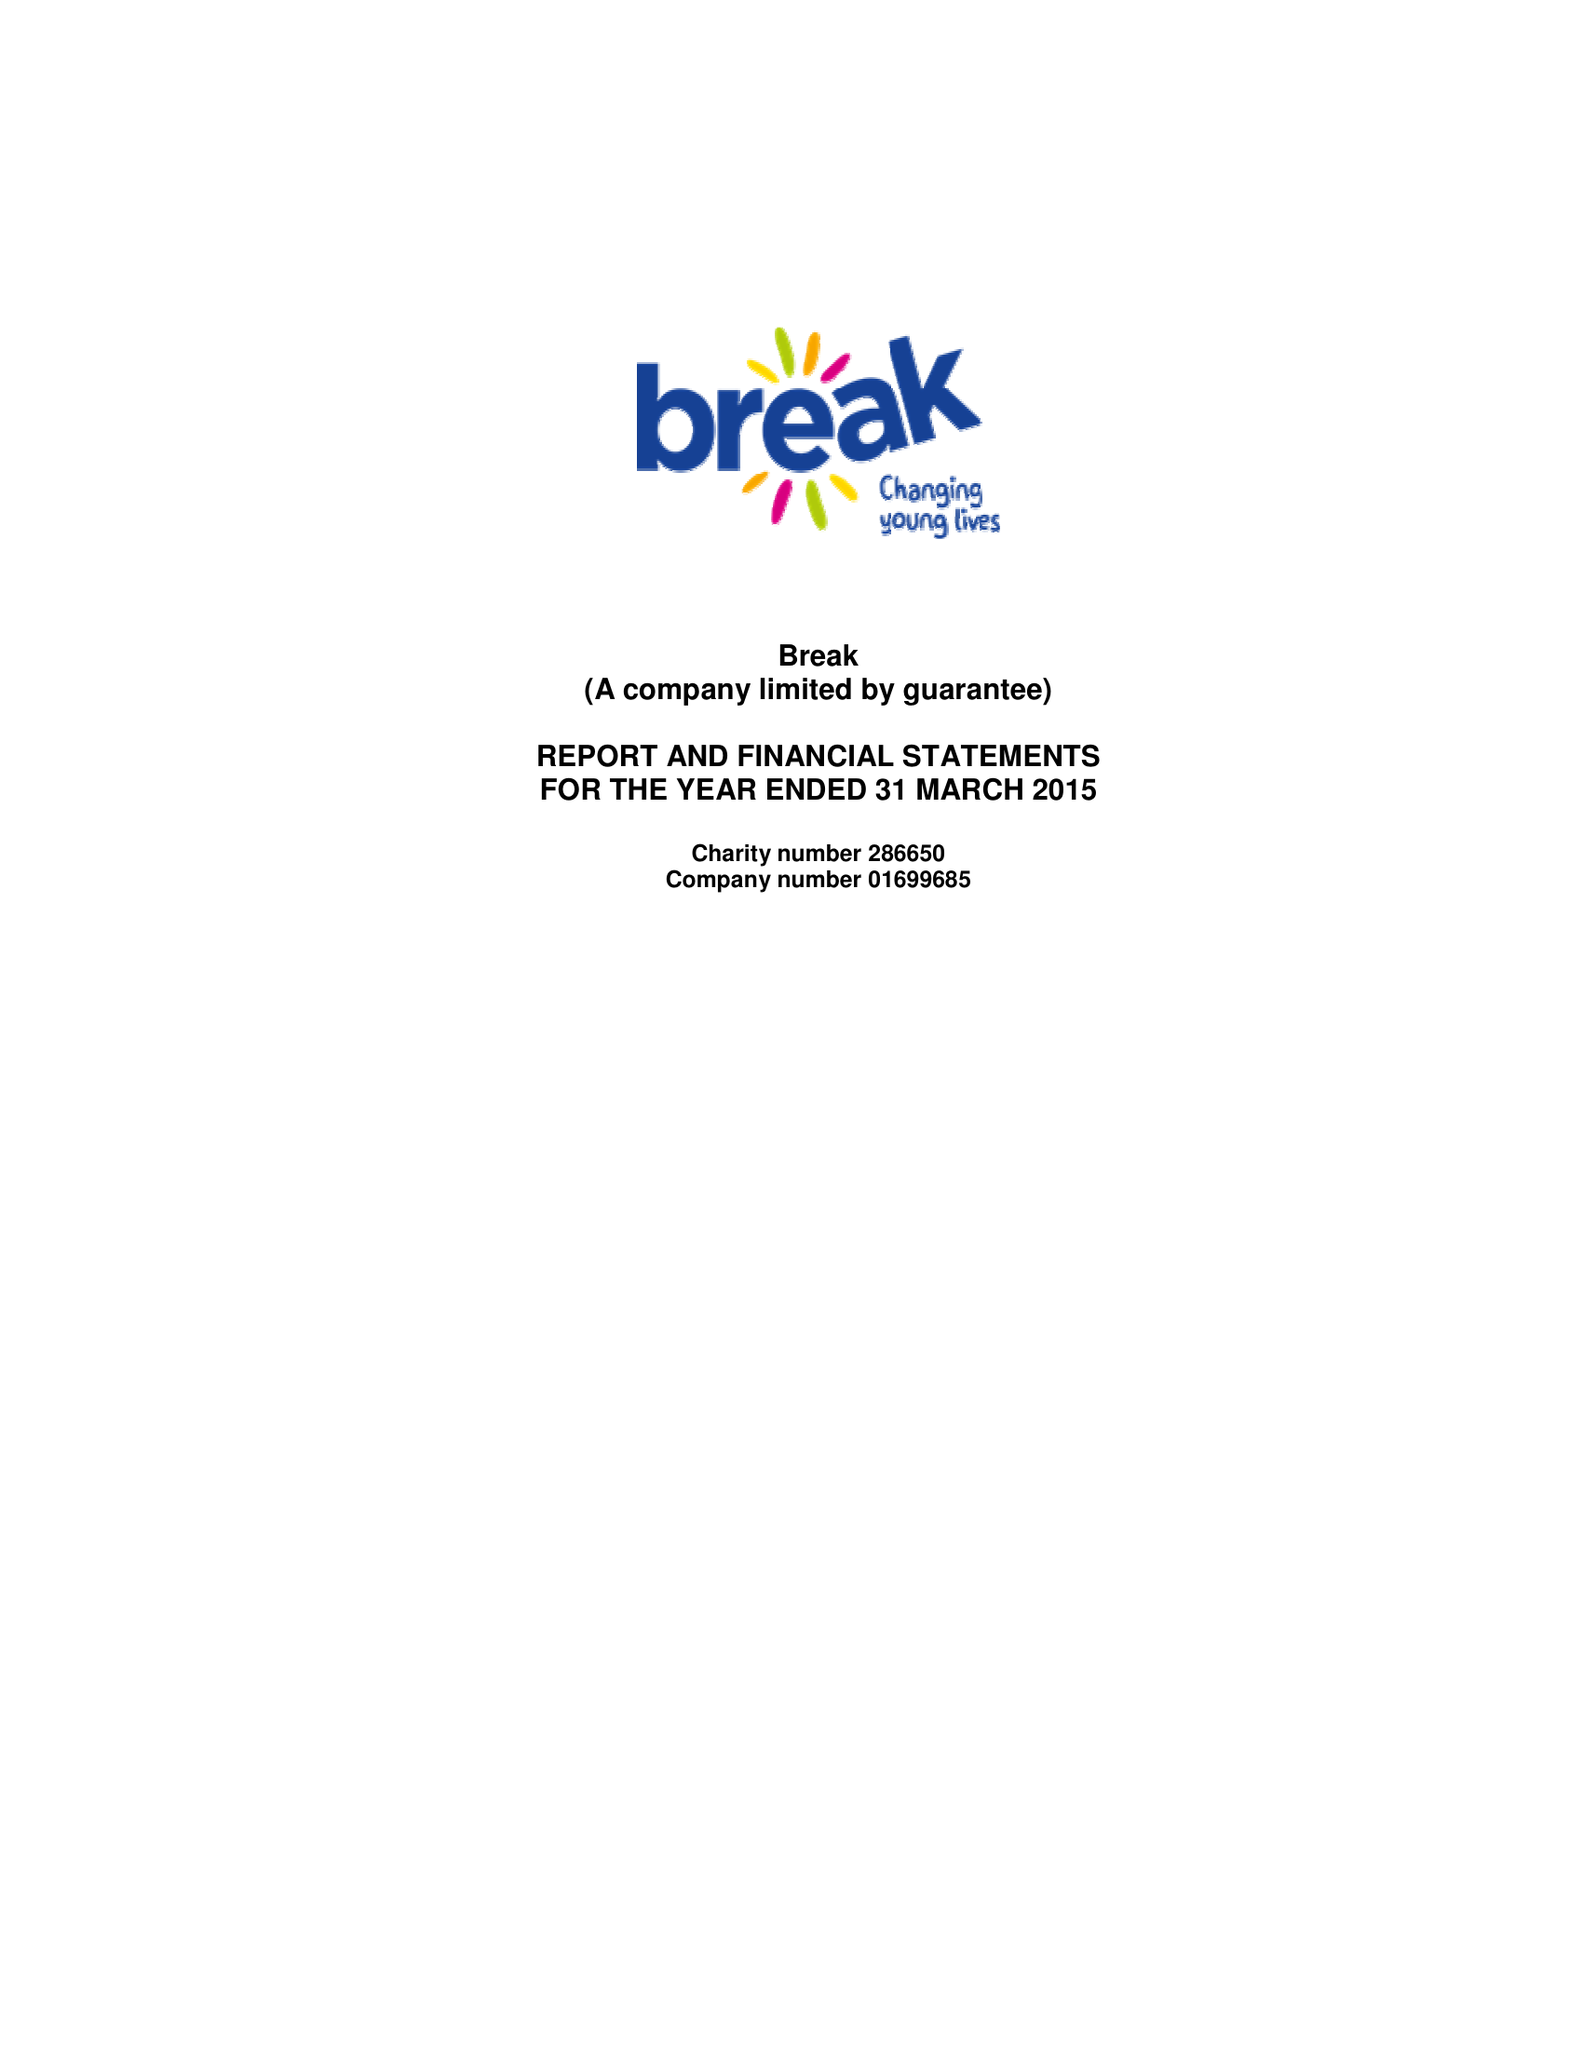What is the value for the report_date?
Answer the question using a single word or phrase. 2015-03-31 